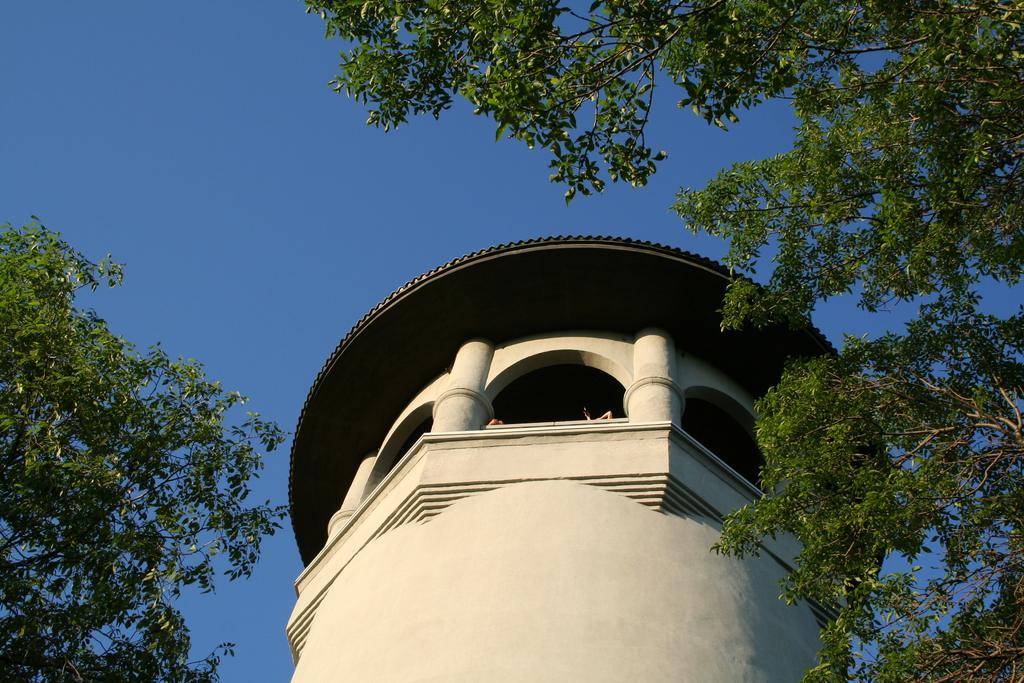Can you describe this image briefly? In this image I can see a building, few trees and sky in background. 